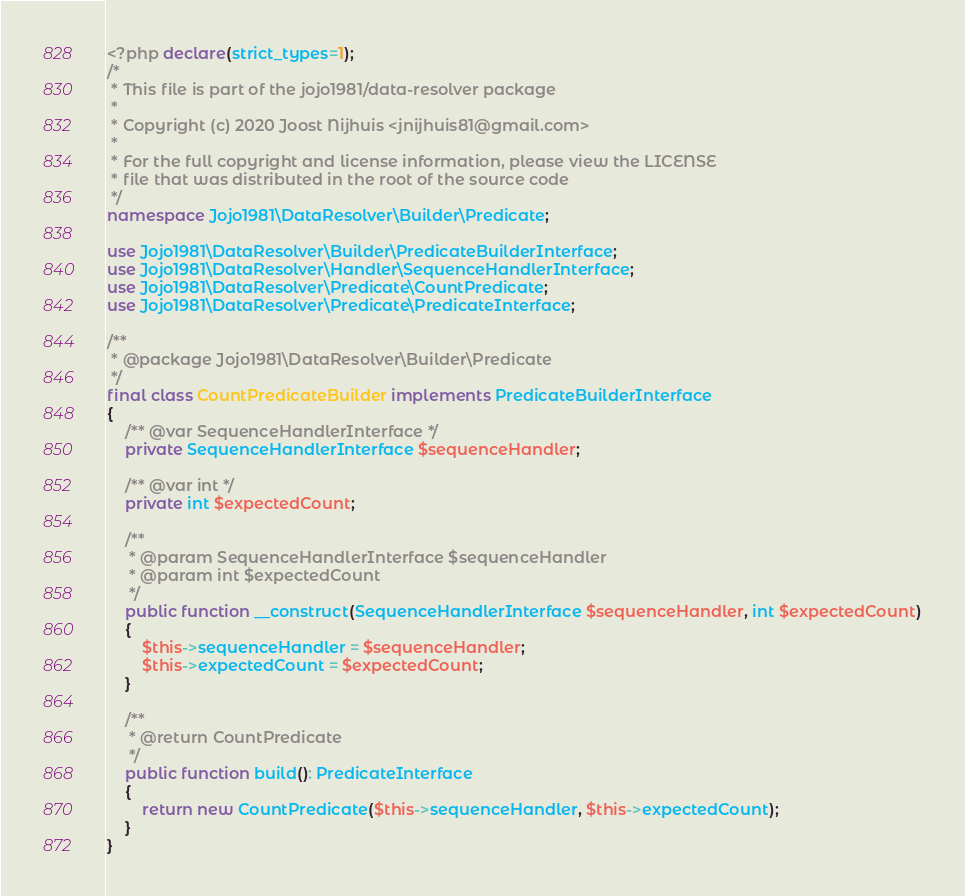<code> <loc_0><loc_0><loc_500><loc_500><_PHP_><?php declare(strict_types=1);
/*
 * This file is part of the jojo1981/data-resolver package
 *
 * Copyright (c) 2020 Joost Nijhuis <jnijhuis81@gmail.com>
 *
 * For the full copyright and license information, please view the LICENSE
 * file that was distributed in the root of the source code
 */
namespace Jojo1981\DataResolver\Builder\Predicate;

use Jojo1981\DataResolver\Builder\PredicateBuilderInterface;
use Jojo1981\DataResolver\Handler\SequenceHandlerInterface;
use Jojo1981\DataResolver\Predicate\CountPredicate;
use Jojo1981\DataResolver\Predicate\PredicateInterface;

/**
 * @package Jojo1981\DataResolver\Builder\Predicate
 */
final class CountPredicateBuilder implements PredicateBuilderInterface
{
    /** @var SequenceHandlerInterface */
    private SequenceHandlerInterface $sequenceHandler;

    /** @var int */
    private int $expectedCount;

    /**
     * @param SequenceHandlerInterface $sequenceHandler
     * @param int $expectedCount
     */
    public function __construct(SequenceHandlerInterface $sequenceHandler, int $expectedCount)
    {
        $this->sequenceHandler = $sequenceHandler;
        $this->expectedCount = $expectedCount;
    }

    /**
     * @return CountPredicate
     */
    public function build(): PredicateInterface
    {
        return new CountPredicate($this->sequenceHandler, $this->expectedCount);
    }
}
</code> 